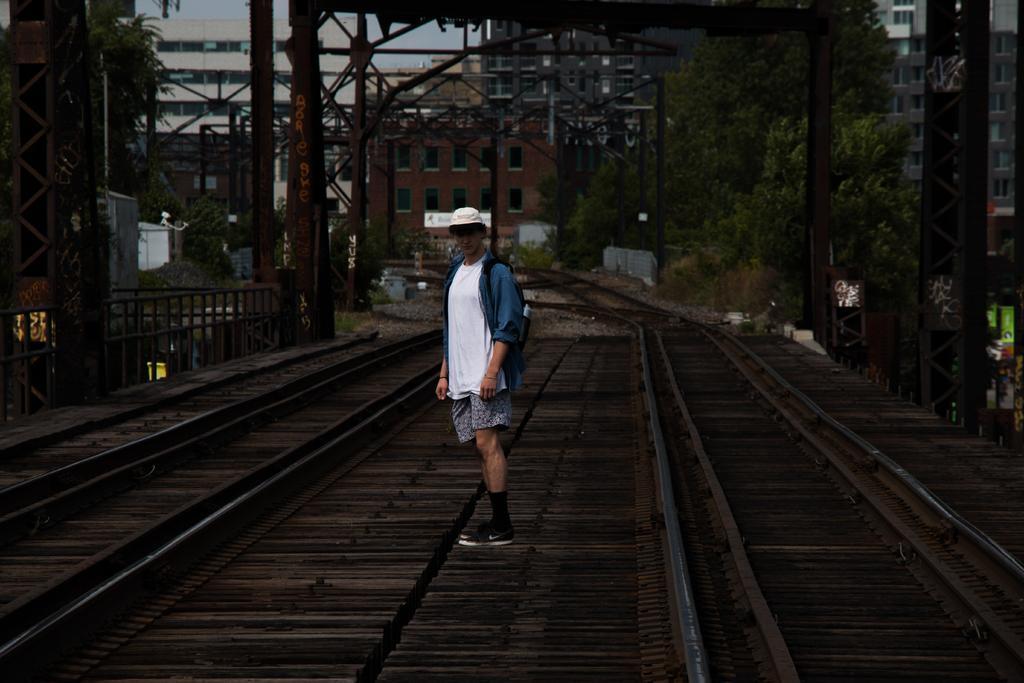Please provide a concise description of this image. In this image there is a person standing in between the tracks, there are a few metal structures and few poles. In the background there are trees and buildings. 